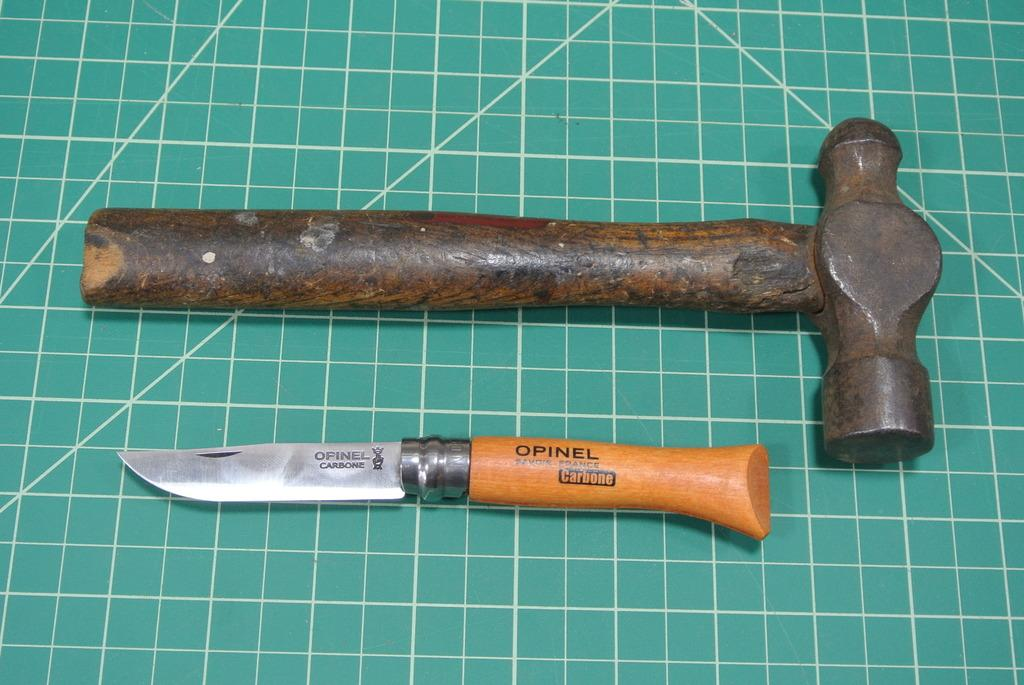What type of tool is present in the image? There is a hammer in the image. What other tool can be seen in the image? There is a knife in the image. What is the color of the surface on which the hammer and knife are placed? The surface on which the hammer and knife are placed is green in color. What type of fiction is being performed on the stage in the image? There is no stage or fiction present in the image; it only features a hammer and a knife on a green surface. What time is displayed on the watch in the image? There is no watch present in the image. 